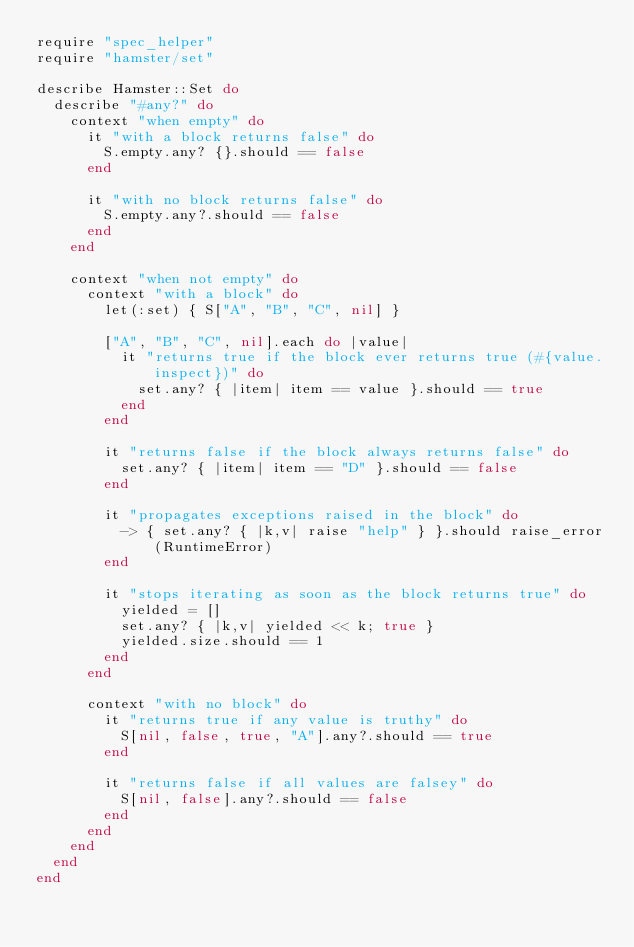Convert code to text. <code><loc_0><loc_0><loc_500><loc_500><_Ruby_>require "spec_helper"
require "hamster/set"

describe Hamster::Set do
  describe "#any?" do
    context "when empty" do
      it "with a block returns false" do
        S.empty.any? {}.should == false
      end

      it "with no block returns false" do
        S.empty.any?.should == false
      end
    end

    context "when not empty" do
      context "with a block" do
        let(:set) { S["A", "B", "C", nil] }

        ["A", "B", "C", nil].each do |value|
          it "returns true if the block ever returns true (#{value.inspect})" do
            set.any? { |item| item == value }.should == true
          end
        end

        it "returns false if the block always returns false" do
          set.any? { |item| item == "D" }.should == false
        end

        it "propagates exceptions raised in the block" do
          -> { set.any? { |k,v| raise "help" } }.should raise_error(RuntimeError)
        end

        it "stops iterating as soon as the block returns true" do
          yielded = []
          set.any? { |k,v| yielded << k; true }
          yielded.size.should == 1
        end
      end

      context "with no block" do
        it "returns true if any value is truthy" do
          S[nil, false, true, "A"].any?.should == true
        end

        it "returns false if all values are falsey" do
          S[nil, false].any?.should == false
        end
      end
    end
  end
end</code> 